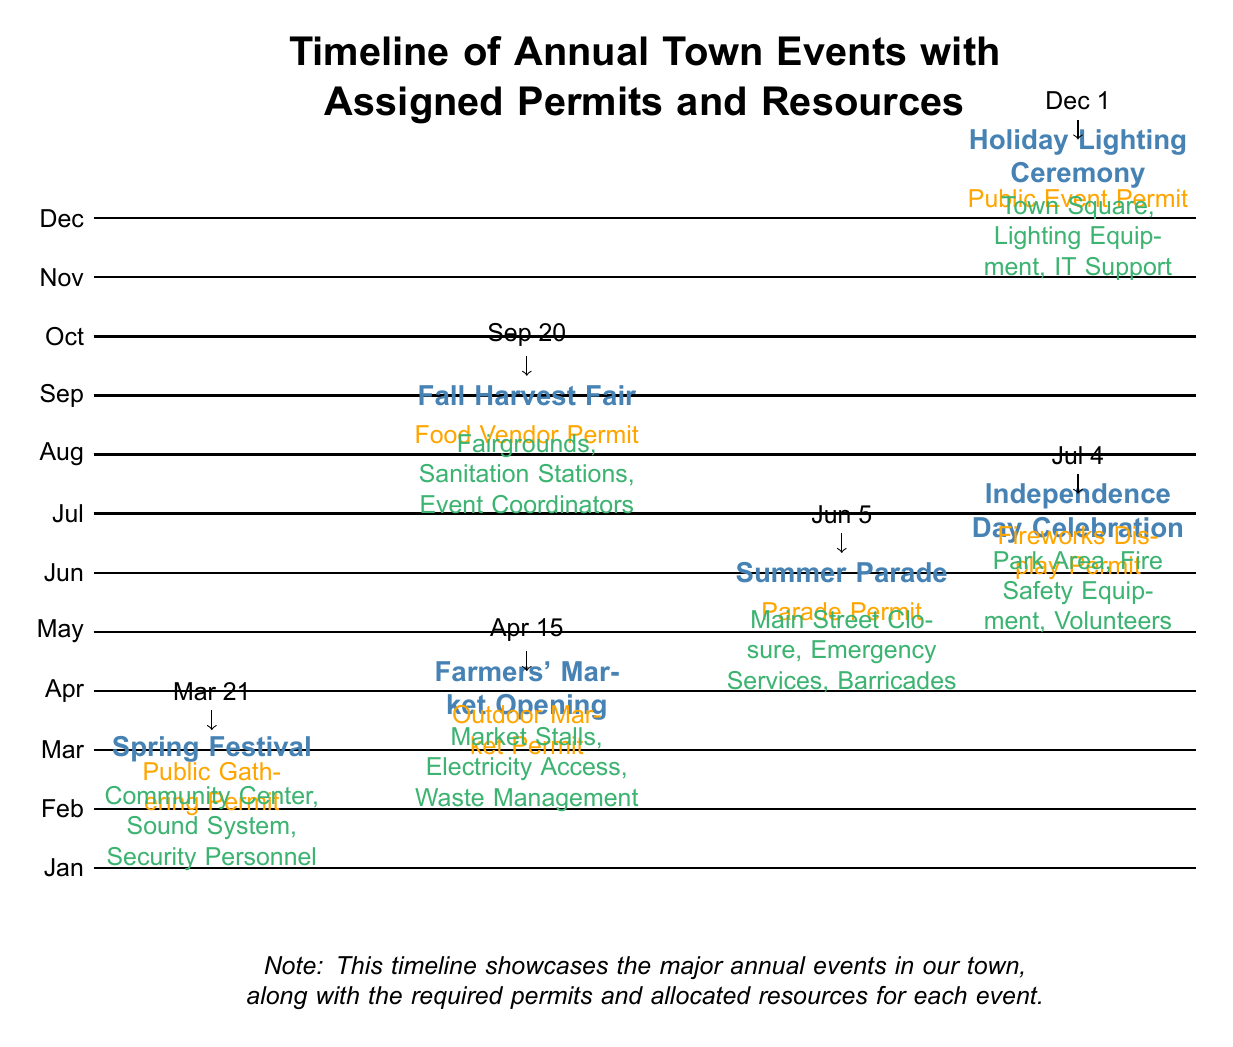What is the first event listed on the timeline? The first event on the timeline is located in March, identified as the Spring Festival. By scanning down the timeline from top to bottom, the Spring Festival is the first event mentioned in the month of March.
Answer: Spring Festival How many permits are listed for the events? To find the number of permits, I can count the distinct permit labels indicated in the timeline. There are a total of six permits, one for each event shown.
Answer: 6 What resource is assigned to the Independence Day Celebration? The Independence Day Celebration has multiple resources allocated, but a key resource mentioned is Fire Safety Equipment. I can find this by looking at the specific node for Independence Day Celebration and reading its associated resources.
Answer: Fire Safety Equipment Which event requires a Public Gathering Permit? By identifying the events and their corresponding permits, the event that specifically requires a Public Gathering Permit is the Spring Festival, since this detail is noted under its specific node.
Answer: Spring Festival How are the events organized in terms of months? The events are organized chronologically based on their occurrence throughout the year, starting with the Spring Festival in March and ending with the Holiday Lighting Ceremony in December. Each event's placement corresponds to its respective month on the timeline.
Answer: Chronologically What month does the Farmers' Market Opening occur? The Farmers' Market Opening is specifically located in the month of April. This can be verified by finding its node on the timeline and relating it to the corresponding month listed.
Answer: April Which event is scheduled for July 4th? The event scheduled for July 4th is the Independence Day Celebration. This date is explicitly indicated by the arrow pointing to the date from the node where this event is detailed.
Answer: Independence Day Celebration What type of permit is needed for the Fall Harvest Fair? The Fall Harvest Fair requires a Food Vendor Permit. This information is displayed under the specific node for the Fair on the timeline, indicating the necessary permit for that event.
Answer: Food Vendor Permit What is the total number of events represented on the timeline? The total number of events can be determined by counting each distinct event listed throughout the timeline. There are six events represented from March to December.
Answer: 6 